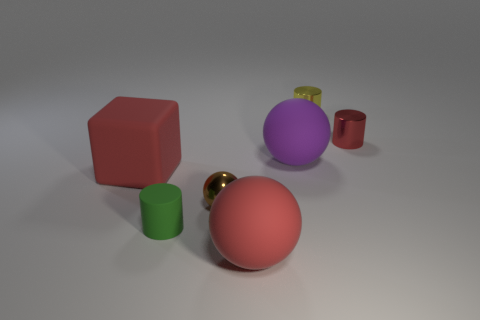There is a rubber sphere that is behind the tiny thing left of the small brown thing; what color is it?
Provide a short and direct response. Purple. What number of other objects are the same color as the small sphere?
Ensure brevity in your answer.  0. How many things are either big matte blocks or balls behind the big block?
Your answer should be compact. 2. There is a matte thing that is behind the matte block; what color is it?
Provide a succinct answer. Purple. There is a green thing; what shape is it?
Offer a terse response. Cylinder. What material is the cylinder on the right side of the object behind the tiny red shiny cylinder?
Give a very brief answer. Metal. What number of other objects are the same material as the small brown sphere?
Keep it short and to the point. 2. What material is the purple thing that is the same size as the cube?
Your response must be concise. Rubber. Are there more tiny shiny objects on the right side of the large purple rubber sphere than tiny cylinders on the right side of the tiny metal sphere?
Provide a short and direct response. No. Are there any large purple objects that have the same shape as the brown thing?
Make the answer very short. Yes. 